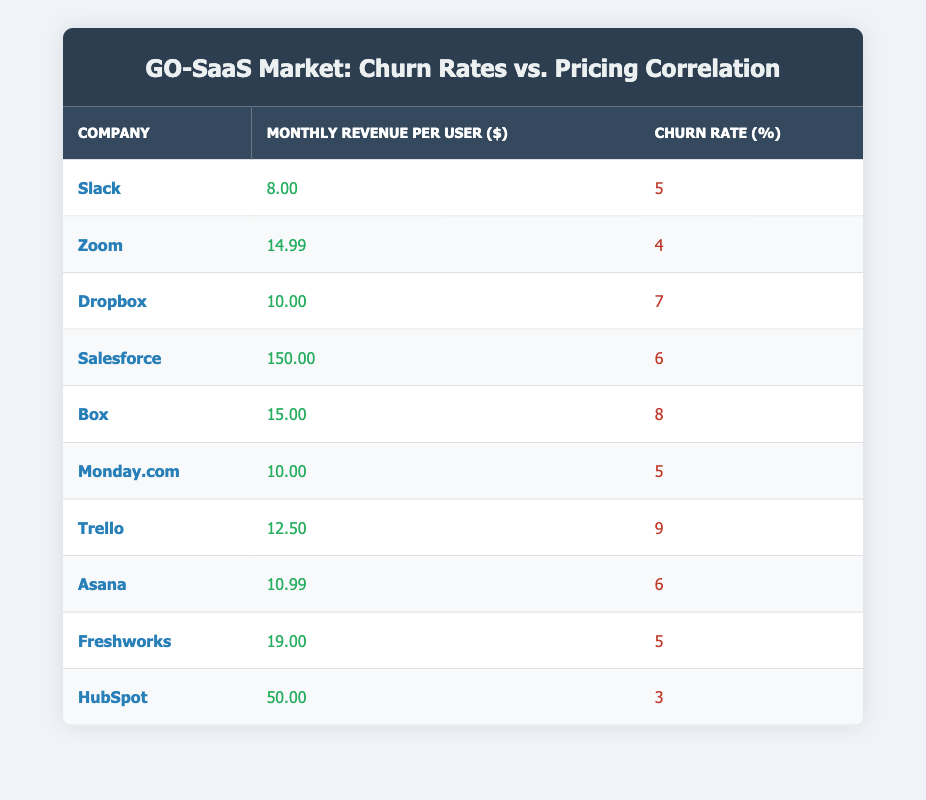What is the monthly revenue per user for HubSpot? The table lists HubSpot's monthly revenue per user as $50.00 under the "Monthly Revenue per User ($)" column.
Answer: 50.00 Which company has the highest churn rate? By examining the "Churn Rate (%)" column, Trello has the highest churn rate at 9%.
Answer: Trello What is the average monthly revenue per user for all companies in the table? To find the average, sum the monthly revenues: 8 + 14.99 + 10 + 150 + 15 + 10 + 12.50 + 10.99 + 19 + 50 = 295.48. There are 10 companies, so the average is 295.48 / 10 = 29.548.
Answer: 29.55 Is there a company with a churn rate of 3%? Checking the "Churn Rate (%)" column, HubSpot shows a churn rate of 3%, confirming that such a company exists.
Answer: Yes What is the total churn rate for companies charging more than $20 per user? Identifying companies that charge over $20 per user: Salesforce (6), Box (8), and Freshworks (5), yields a total churn rate of 6 + 8 + 5 = 19%.
Answer: 19% How many companies have a churn rate less than 5%? Reviewing the table shows that only HubSpot, with a churn rate of 3%, falls below 5%. Thus, there is just one company.
Answer: 1 Is the total revenue generated by companies with a churn rate of 5% higher than $50? The companies with a churn rate of 5% are Slack, Monday.com, and Freshworks, with revenues of 8, 10, and 19 respectively. Total revenue = 8 + 10 + 19 = 37, which is less than 50.
Answer: No What is the difference in churn rates between Zoom and Salesforce? The churn rate for Zoom is 4%, while for Salesforce it is 6%. The difference is 6 - 4 = 2%.
Answer: 2% Which company has the lowest churn rate and what is the value? By comparing the churn rates in the table, HubSpot has the lowest churn rate at 3%.
Answer: HubSpot, 3% 